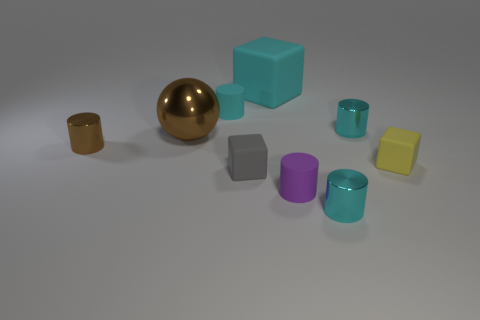Subtract all cyan cylinders. How many were subtracted if there are1cyan cylinders left? 2 Subtract all large cyan rubber blocks. How many blocks are left? 2 Subtract all yellow cubes. How many cyan cylinders are left? 3 Add 1 tiny brown blocks. How many objects exist? 10 Subtract all cyan cylinders. How many cylinders are left? 2 Subtract 1 balls. How many balls are left? 0 Subtract all cylinders. How many objects are left? 4 Subtract all yellow cylinders. Subtract all purple spheres. How many cylinders are left? 5 Subtract all small brown cylinders. Subtract all matte objects. How many objects are left? 3 Add 2 gray matte cubes. How many gray matte cubes are left? 3 